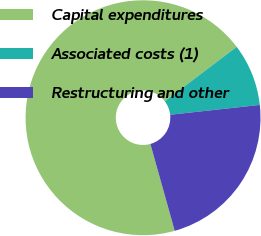<chart> <loc_0><loc_0><loc_500><loc_500><pie_chart><fcel>Capital expenditures<fcel>Associated costs (1)<fcel>Restructuring and other<nl><fcel>69.03%<fcel>8.58%<fcel>22.39%<nl></chart> 